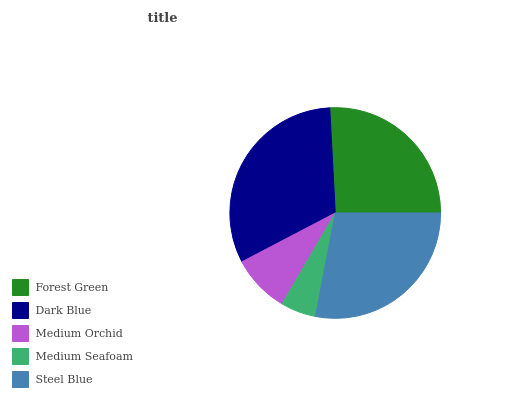Is Medium Seafoam the minimum?
Answer yes or no. Yes. Is Dark Blue the maximum?
Answer yes or no. Yes. Is Medium Orchid the minimum?
Answer yes or no. No. Is Medium Orchid the maximum?
Answer yes or no. No. Is Dark Blue greater than Medium Orchid?
Answer yes or no. Yes. Is Medium Orchid less than Dark Blue?
Answer yes or no. Yes. Is Medium Orchid greater than Dark Blue?
Answer yes or no. No. Is Dark Blue less than Medium Orchid?
Answer yes or no. No. Is Forest Green the high median?
Answer yes or no. Yes. Is Forest Green the low median?
Answer yes or no. Yes. Is Medium Orchid the high median?
Answer yes or no. No. Is Medium Orchid the low median?
Answer yes or no. No. 